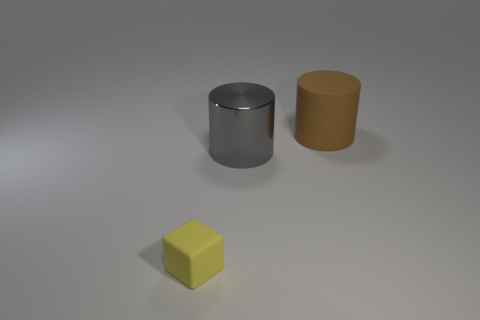How many other objects are there of the same size as the brown rubber object?
Make the answer very short. 1. How many small yellow objects are left of the matte object on the right side of the small matte object?
Make the answer very short. 1. Is the number of small rubber cubes that are behind the small yellow object less than the number of small blue spheres?
Your answer should be very brief. No. What is the shape of the rubber object to the right of the large thing in front of the rubber thing behind the yellow matte object?
Your answer should be very brief. Cylinder. Does the brown matte object have the same shape as the big shiny thing?
Your response must be concise. Yes. How many other objects are the same shape as the small rubber object?
Ensure brevity in your answer.  0. What color is the other cylinder that is the same size as the brown rubber cylinder?
Offer a terse response. Gray. Are there an equal number of big matte things to the left of the brown thing and cylinders?
Your response must be concise. No. The thing that is in front of the big rubber cylinder and on the right side of the yellow matte cube has what shape?
Provide a succinct answer. Cylinder. Do the shiny cylinder and the yellow rubber block have the same size?
Offer a terse response. No. 